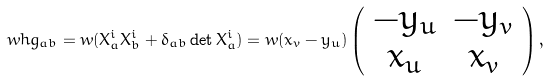<formula> <loc_0><loc_0><loc_500><loc_500>\ w h g _ { a b } = w ( X _ { a } ^ { i } X _ { b } ^ { i } + \delta _ { a b } \det X _ { a } ^ { i } ) = w ( x _ { v } - y _ { u } ) \left ( \begin{array} { c c } - y _ { u } & - y _ { v } \\ x _ { u } & x _ { v } \end{array} \right ) ,</formula> 